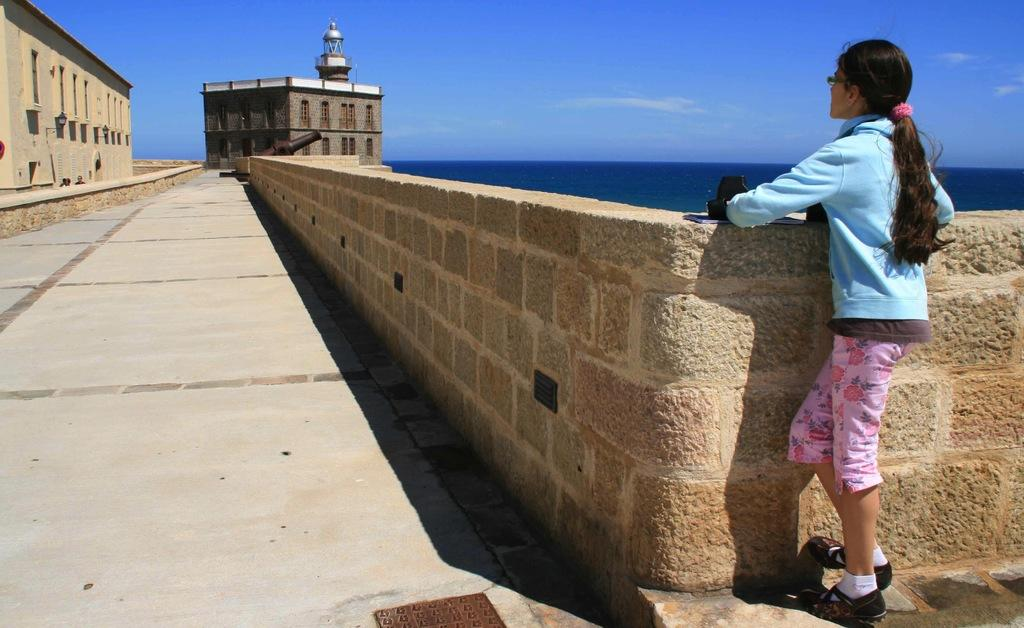What is the main subject of the image? There is a person standing in front of a wall. What can be seen in the background of the image? Buildings, windows, and water are visible in the image. Are there any other people present in the image? Yes, there are people visible in the image. What is the color of the sky in the image? The sky is blue and white in color. What type of plants can be seen growing near the water in the image? There are no plants visible in the image. Is there any coal present in the image? There is no coal present in the image. 